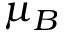Convert formula to latex. <formula><loc_0><loc_0><loc_500><loc_500>\mu _ { B }</formula> 